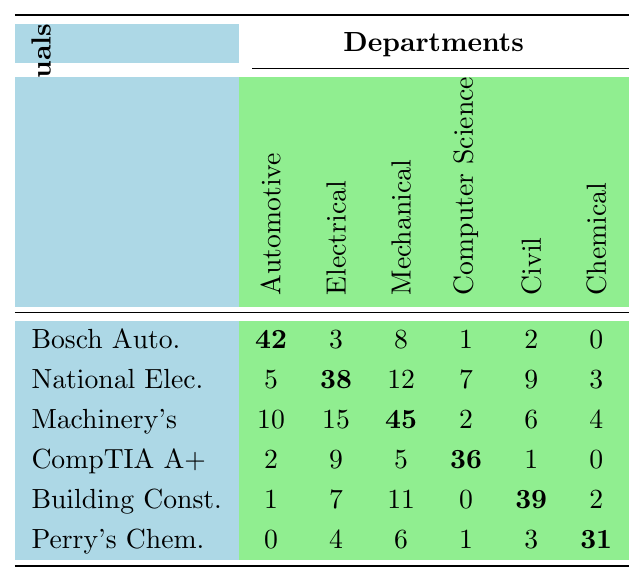What is the highest borrowing frequency for the "Bosch Automotive Handbook"? Looking at the table, the borrowing frequency for the "Bosch Automotive Handbook" is 42 for the Automotive Technology department, which is the highest value in that row.
Answer: 42 Which department borrowed "Perry's Chemical Engineers' Handbook" the most? The Department of Chemical Engineering borrowed "Perry's Chemical Engineers' Handbook" 31 times, which is the highest borrowing frequency for that manual across all departments.
Answer: Chemical Engineering What is the average borrowing frequency for the "CompTIA A+ Certification Guide"? The borrowing frequencies for the "CompTIA A+ Certification Guide" across the departments are 2, 9, 5, 36, 1, and 0. The sum is 53 and there are 6 departments. Thus, the average is 53/6 ≈ 8.83.
Answer: Approximately 8.83 Which manual has the lowest overall borrowing frequency? By examining the row totals, the "Perry's Chemical Engineers' Handbook" totals to 44, which is lower than any other manual's total.
Answer: Perry's Chemical Engineers' Handbook Did the Mechanical Engineering department borrow more technical manuals than the Computer Science department? The borrowing frequencies for Mechanical Engineering are 45, 2, 6, and 4, totaling 57. For Computer Science, the frequencies are 1, 7, 36, and 0, totaling 44. Since 57 > 44, Mechanical Engineering borrowed more.
Answer: Yes What is the difference in borrowing frequency of "National Electrical Code" between Electrical Engineering and Civil Engineering? The borrowing frequency for "National Electrical Code" is 38 in the Electrical Engineering department and 9 in the Civil Engineering department. The difference is 38 - 9 = 29.
Answer: 29 Find the total number of times all departments borrowed the "Machinery's Handbook". The borrowing frequencies for "Machinery's Handbook" are 10, 15, 45, 2, 6, and 4. Adding these values gives 10 + 15 + 45 + 2 + 6 + 4 = 82.
Answer: 82 Which department borrowed the most manuals in total? Adding all borrowing frequencies for each department gives: Automotive Technology (56), Electrical Engineering (74), Mechanical Engineering (82), Computer Science (49), Civil Engineering (59), and Chemical Engineering (45). The maximum total is 82 for Mechanical Engineering.
Answer: Mechanical Engineering Is it true that Civil Engineering borrowed more technical manuals than Electrical Engineering? From the total borrowing frequencies calculated earlier: Civil Engineering (59) and Electrical Engineering (74), it is clear that Civil Engineering borrowed less than Electrical Engineering.
Answer: No What is the total borrowing frequency across all manuals for the Automotive Technology department? The borrowing frequencies for the Automotive Technology department are 42, 5, 10, 2, 1, and 0. Summing these gives 42 + 5 + 10 + 2 + 1 + 0 = 60.
Answer: 60 